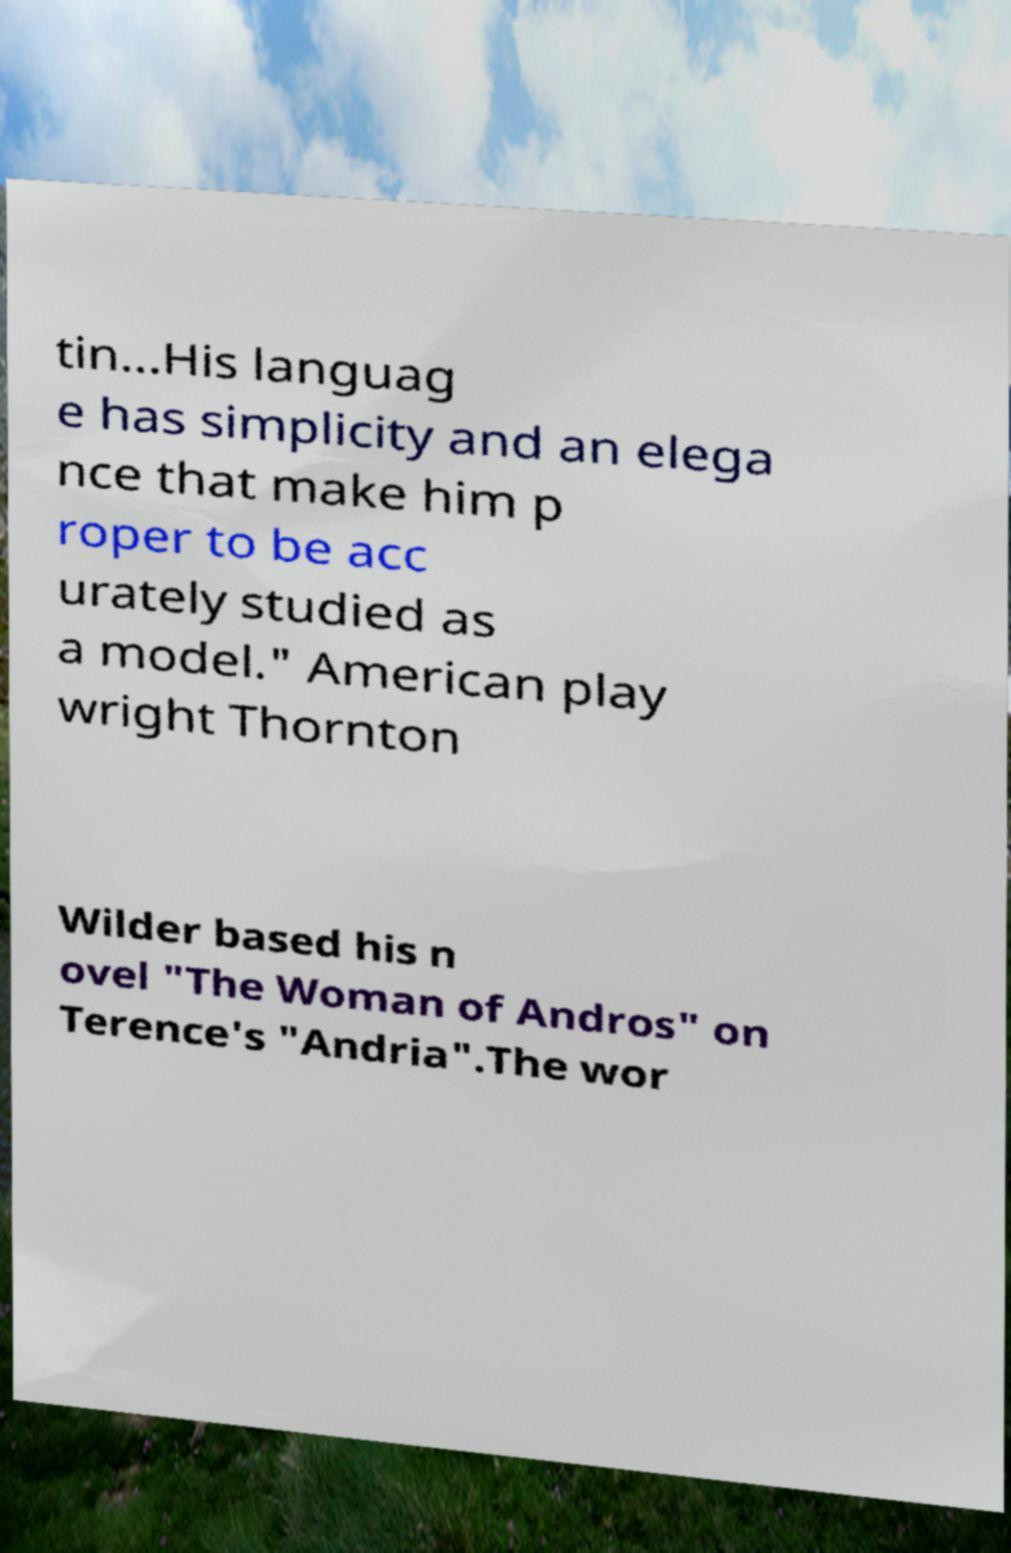Please read and relay the text visible in this image. What does it say? tin...His languag e has simplicity and an elega nce that make him p roper to be acc urately studied as a model." American play wright Thornton Wilder based his n ovel "The Woman of Andros" on Terence's "Andria".The wor 